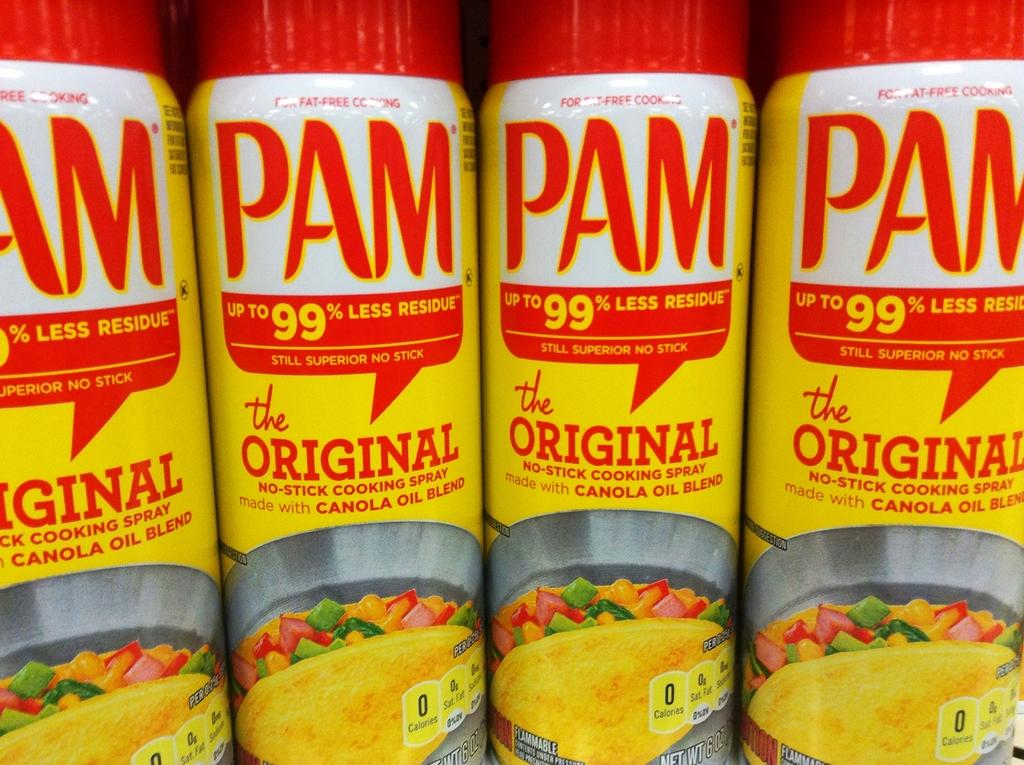What can be seen on the shelves in the image? There are objects placed on shelves in the image. Can you hear the sound of a goat in the image? There is no sound or goat present in the image, as it is a still image. What type of weather is depicted in the image? The image does not depict any weather conditions, as it only shows objects placed on shelves. 